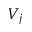<formula> <loc_0><loc_0><loc_500><loc_500>V _ { j }</formula> 